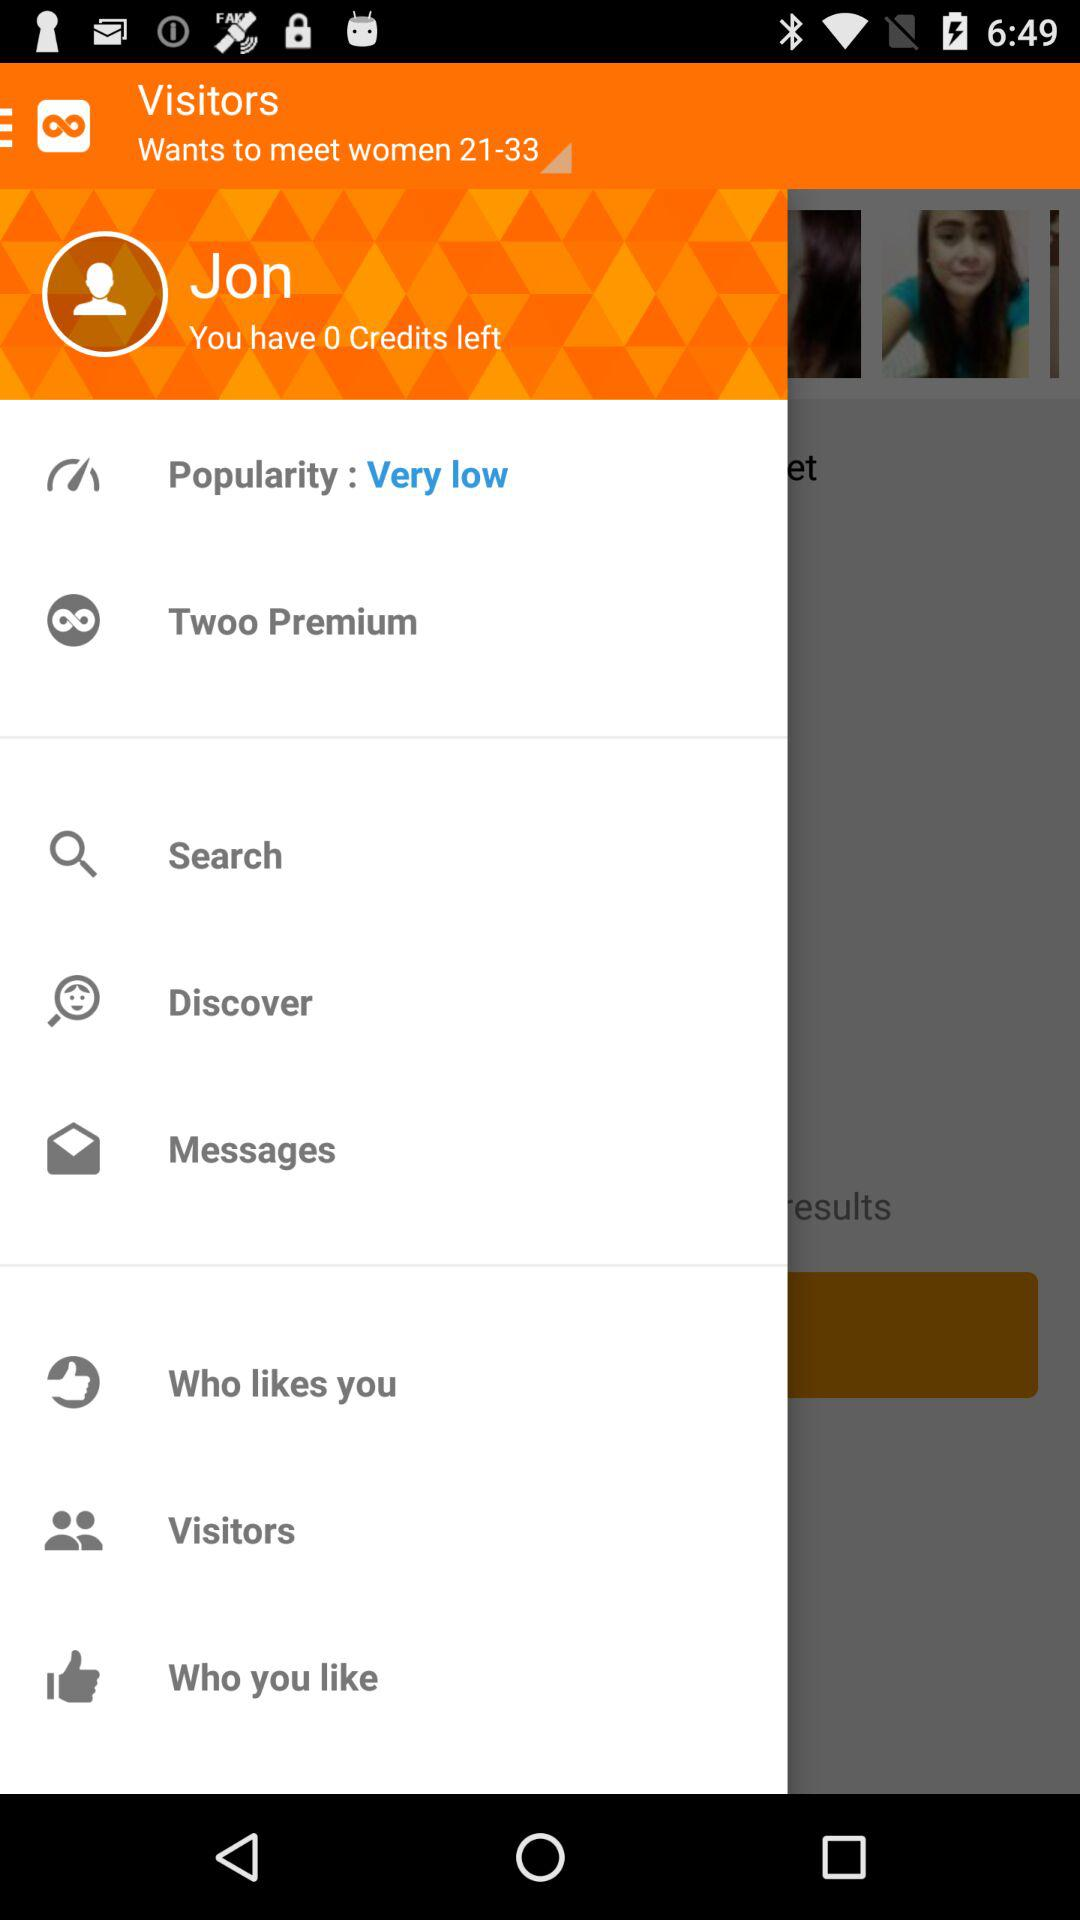What is the user name? The user name is Jon. 